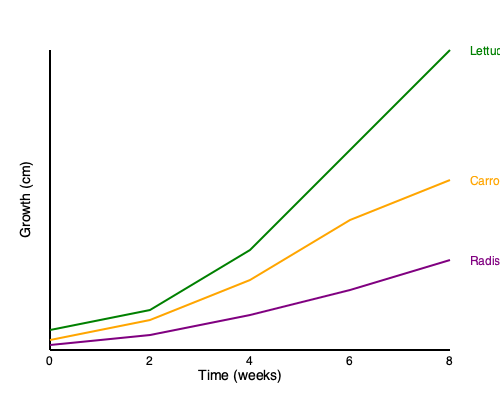Based on the growth chart of lettuce, carrots, and radishes over 8 weeks, which vegetable shows the highest average weekly growth rate, and what is its approximate value in cm/week? To solve this problem, we need to follow these steps:

1. Calculate the total growth for each vegetable:
   - Lettuce: From 20cm to 300cm = 280cm
   - Carrots: From 10cm to 170cm = 160cm
   - Radishes: From 5cm to 90cm = 85cm

2. Calculate the average weekly growth rate:
   Average weekly growth rate = Total growth / Number of weeks

   For lettuce:
   $\frac{280 \text{ cm}}{8 \text{ weeks}} = 35 \text{ cm/week}$

   For carrots:
   $\frac{160 \text{ cm}}{8 \text{ weeks}} = 20 \text{ cm/week}$

   For radishes:
   $\frac{85 \text{ cm}}{8 \text{ weeks}} = 10.625 \text{ cm/week}$

3. Compare the growth rates:
   Lettuce has the highest average weekly growth rate at 35 cm/week.

Therefore, lettuce shows the highest average weekly growth rate at approximately 35 cm/week.
Answer: Lettuce, 35 cm/week 